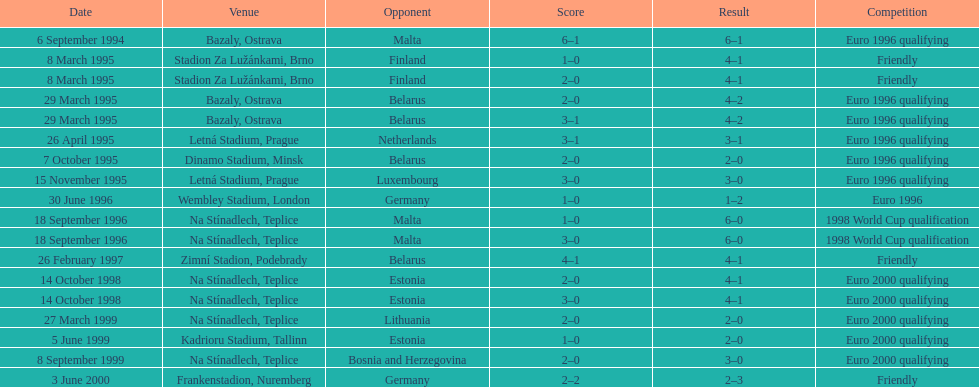How many euro 2000 qualifying competitions are listed? 4. 